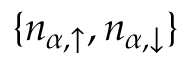<formula> <loc_0><loc_0><loc_500><loc_500>\{ n _ { { \alpha } , \uparrow } , n _ { { \alpha } , \downarrow } \}</formula> 